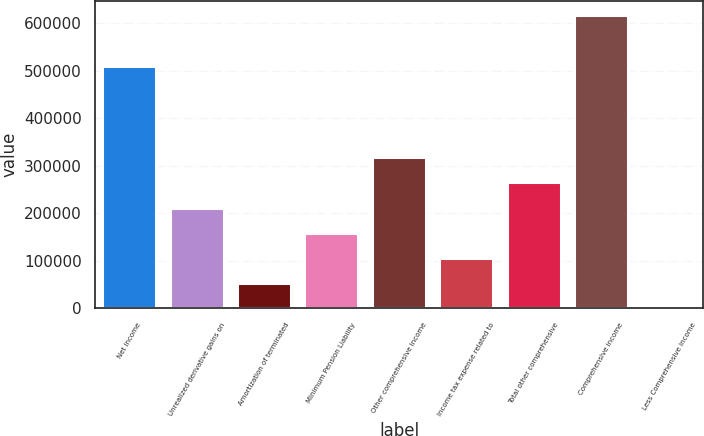Convert chart to OTSL. <chart><loc_0><loc_0><loc_500><loc_500><bar_chart><fcel>Net income<fcel>Unrealized derivative gains on<fcel>Amortization of terminated<fcel>Minimum Pension Liability<fcel>Other comprehensive income<fcel>Income tax expense related to<fcel>Total other comprehensive<fcel>Comprehensive income<fcel>Less Comprehensive income<nl><fcel>510733<fcel>212032<fcel>53010<fcel>159025<fcel>318047<fcel>106017<fcel>265040<fcel>616748<fcel>2.52<nl></chart> 